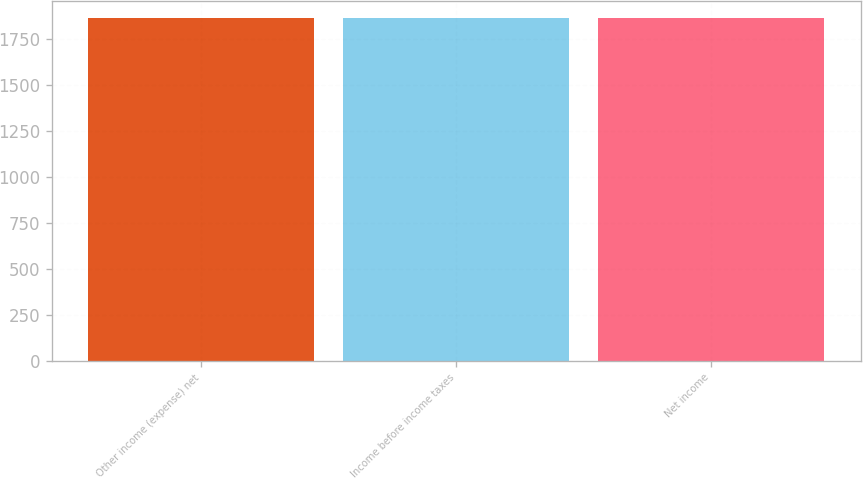Convert chart to OTSL. <chart><loc_0><loc_0><loc_500><loc_500><bar_chart><fcel>Other income (expense) net<fcel>Income before income taxes<fcel>Net income<nl><fcel>1864<fcel>1864.1<fcel>1864.2<nl></chart> 